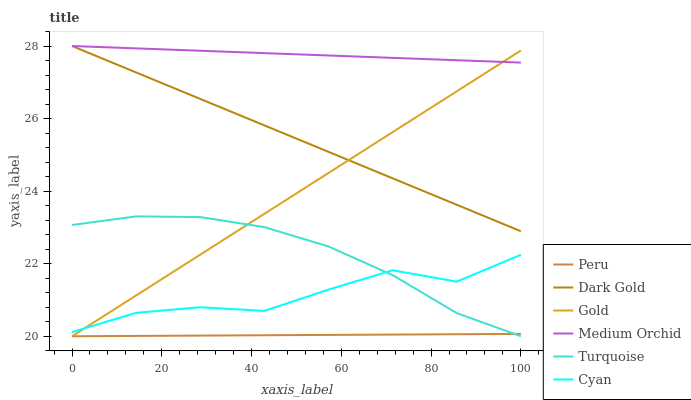Does Peru have the minimum area under the curve?
Answer yes or no. Yes. Does Medium Orchid have the maximum area under the curve?
Answer yes or no. Yes. Does Gold have the minimum area under the curve?
Answer yes or no. No. Does Gold have the maximum area under the curve?
Answer yes or no. No. Is Medium Orchid the smoothest?
Answer yes or no. Yes. Is Cyan the roughest?
Answer yes or no. Yes. Is Gold the smoothest?
Answer yes or no. No. Is Gold the roughest?
Answer yes or no. No. Does Turquoise have the lowest value?
Answer yes or no. Yes. Does Dark Gold have the lowest value?
Answer yes or no. No. Does Medium Orchid have the highest value?
Answer yes or no. Yes. Does Gold have the highest value?
Answer yes or no. No. Is Cyan less than Dark Gold?
Answer yes or no. Yes. Is Dark Gold greater than Cyan?
Answer yes or no. Yes. Does Peru intersect Turquoise?
Answer yes or no. Yes. Is Peru less than Turquoise?
Answer yes or no. No. Is Peru greater than Turquoise?
Answer yes or no. No. Does Cyan intersect Dark Gold?
Answer yes or no. No. 